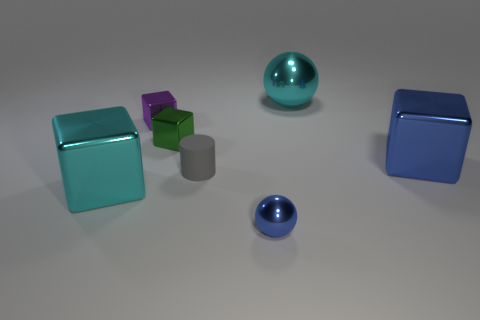The metal thing that is both in front of the gray object and to the right of the gray matte object has what shape?
Your answer should be compact. Sphere. There is a cube to the right of the tiny gray thing; what size is it?
Provide a succinct answer. Large. Is the cyan metallic block the same size as the cyan sphere?
Your response must be concise. Yes. Is the number of tiny shiny spheres that are on the left side of the tiny green metallic block less than the number of big objects behind the cylinder?
Give a very brief answer. Yes. What is the size of the cube that is in front of the green shiny block and on the left side of the cyan metallic sphere?
Provide a succinct answer. Large. There is a cyan metal thing behind the object left of the purple object; are there any large cyan objects that are in front of it?
Your answer should be very brief. Yes. Are there any purple blocks?
Provide a short and direct response. Yes. Are there more large cubes behind the cyan block than cyan spheres in front of the big metal sphere?
Your response must be concise. Yes. What size is the blue cube that is the same material as the tiny green thing?
Offer a very short reply. Large. There is a cyan object in front of the shiny block to the right of the big shiny thing that is behind the tiny purple shiny thing; how big is it?
Make the answer very short. Large. 